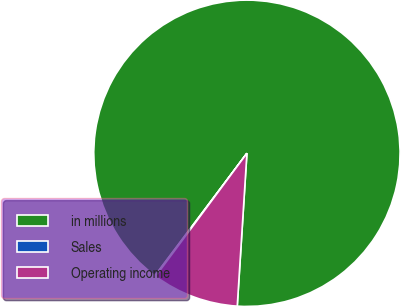Convert chart. <chart><loc_0><loc_0><loc_500><loc_500><pie_chart><fcel>in millions<fcel>Sales<fcel>Operating income<nl><fcel>90.75%<fcel>0.09%<fcel>9.16%<nl></chart> 